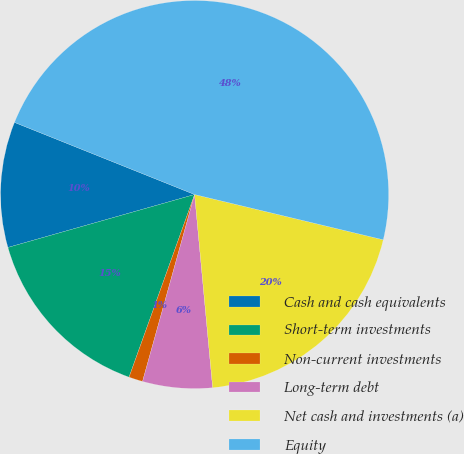<chart> <loc_0><loc_0><loc_500><loc_500><pie_chart><fcel>Cash and cash equivalents<fcel>Short-term investments<fcel>Non-current investments<fcel>Long-term debt<fcel>Net cash and investments (a)<fcel>Equity<nl><fcel>10.46%<fcel>15.12%<fcel>1.16%<fcel>5.81%<fcel>19.77%<fcel>47.69%<nl></chart> 